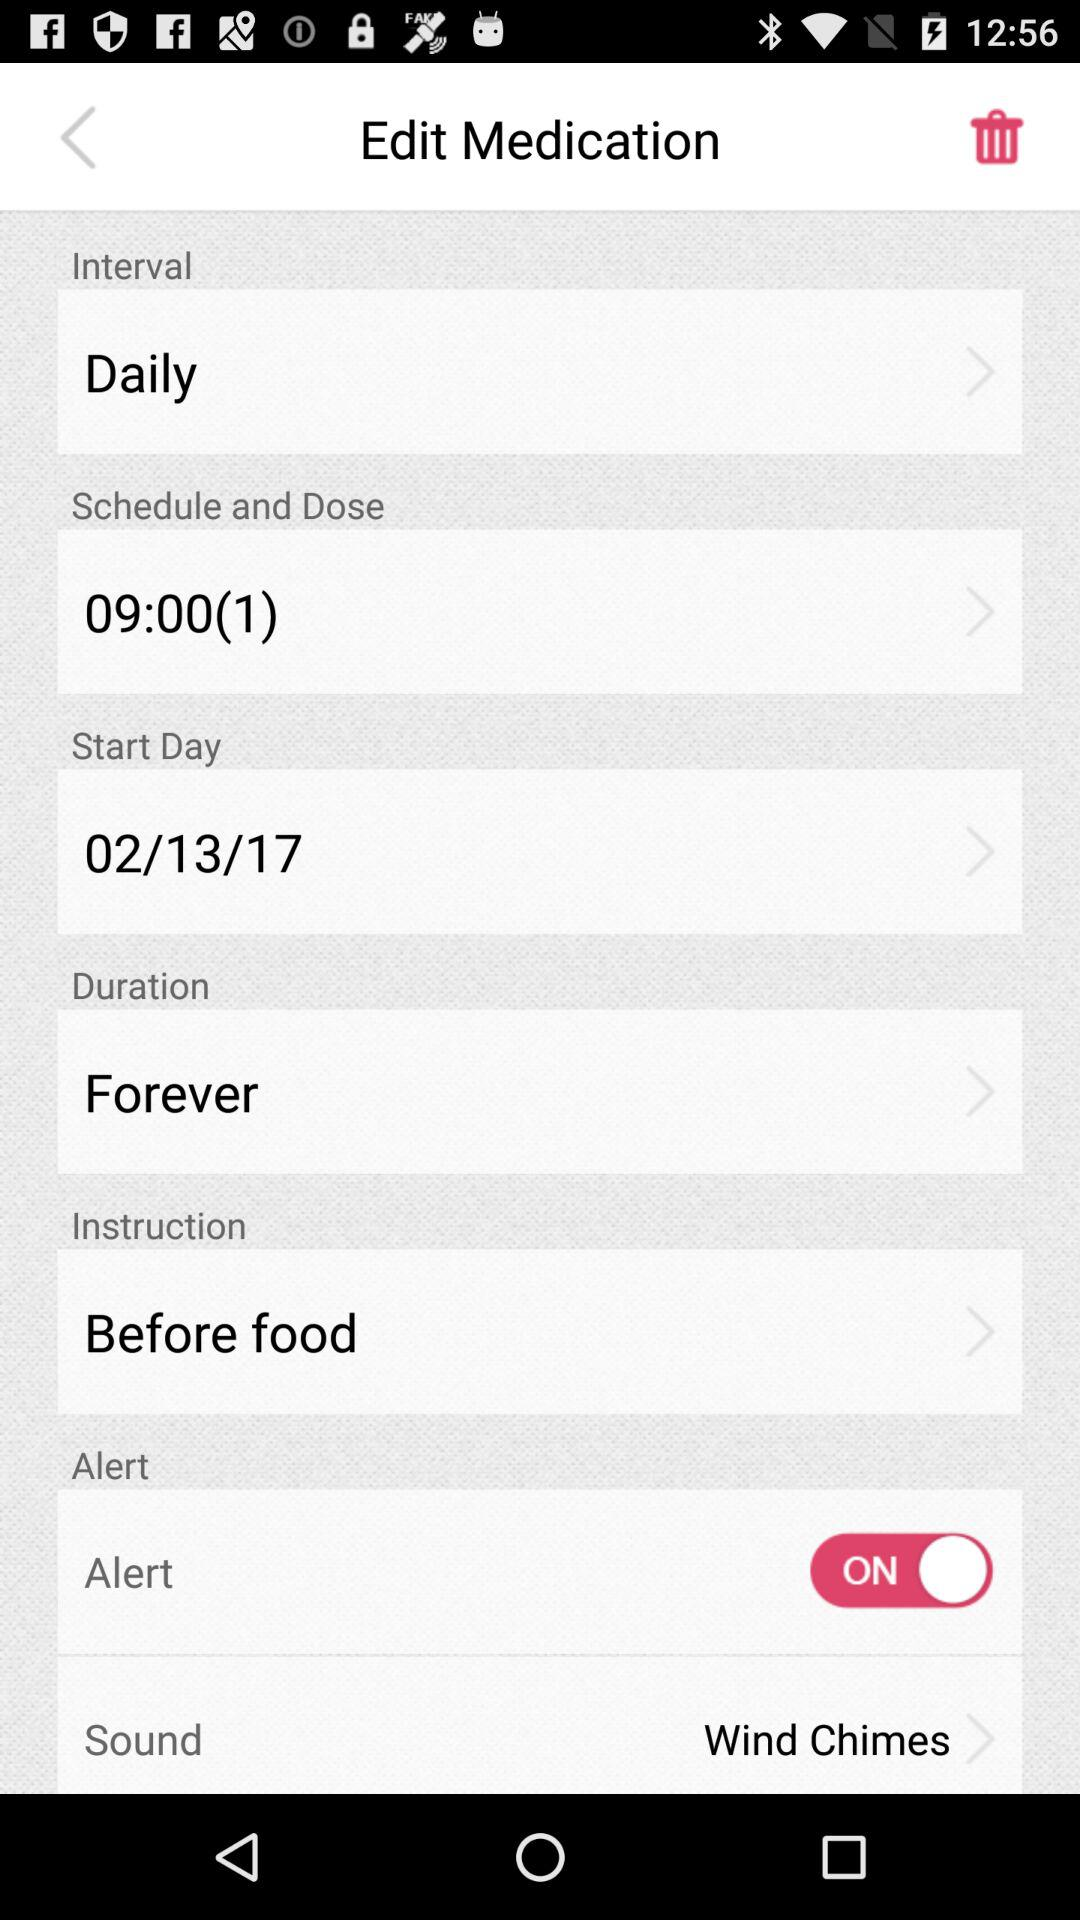What is the instruction given for medication? The instruction is "Before food". 